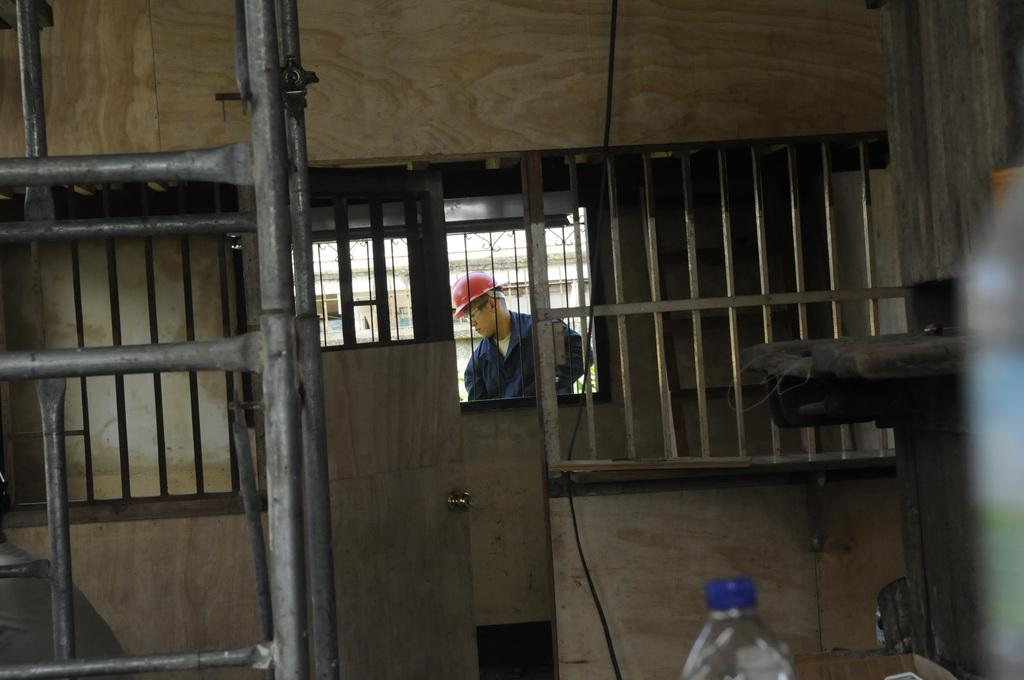What is happening outside the window in the image? There is a man standing outside the window. What is the man wearing on his head? The man is wearing a red helmet. What can be seen inside the room in the image? There is a door and a ladder visible inside the room. What object can be seen near the ladder? There is a bottle in the image. Can you see any worms crawling on the ladder in the image? There are no worms visible in the image, as it features a man wearing a red helmet outside a window, a door, a ladder, and a bottle inside the room. 